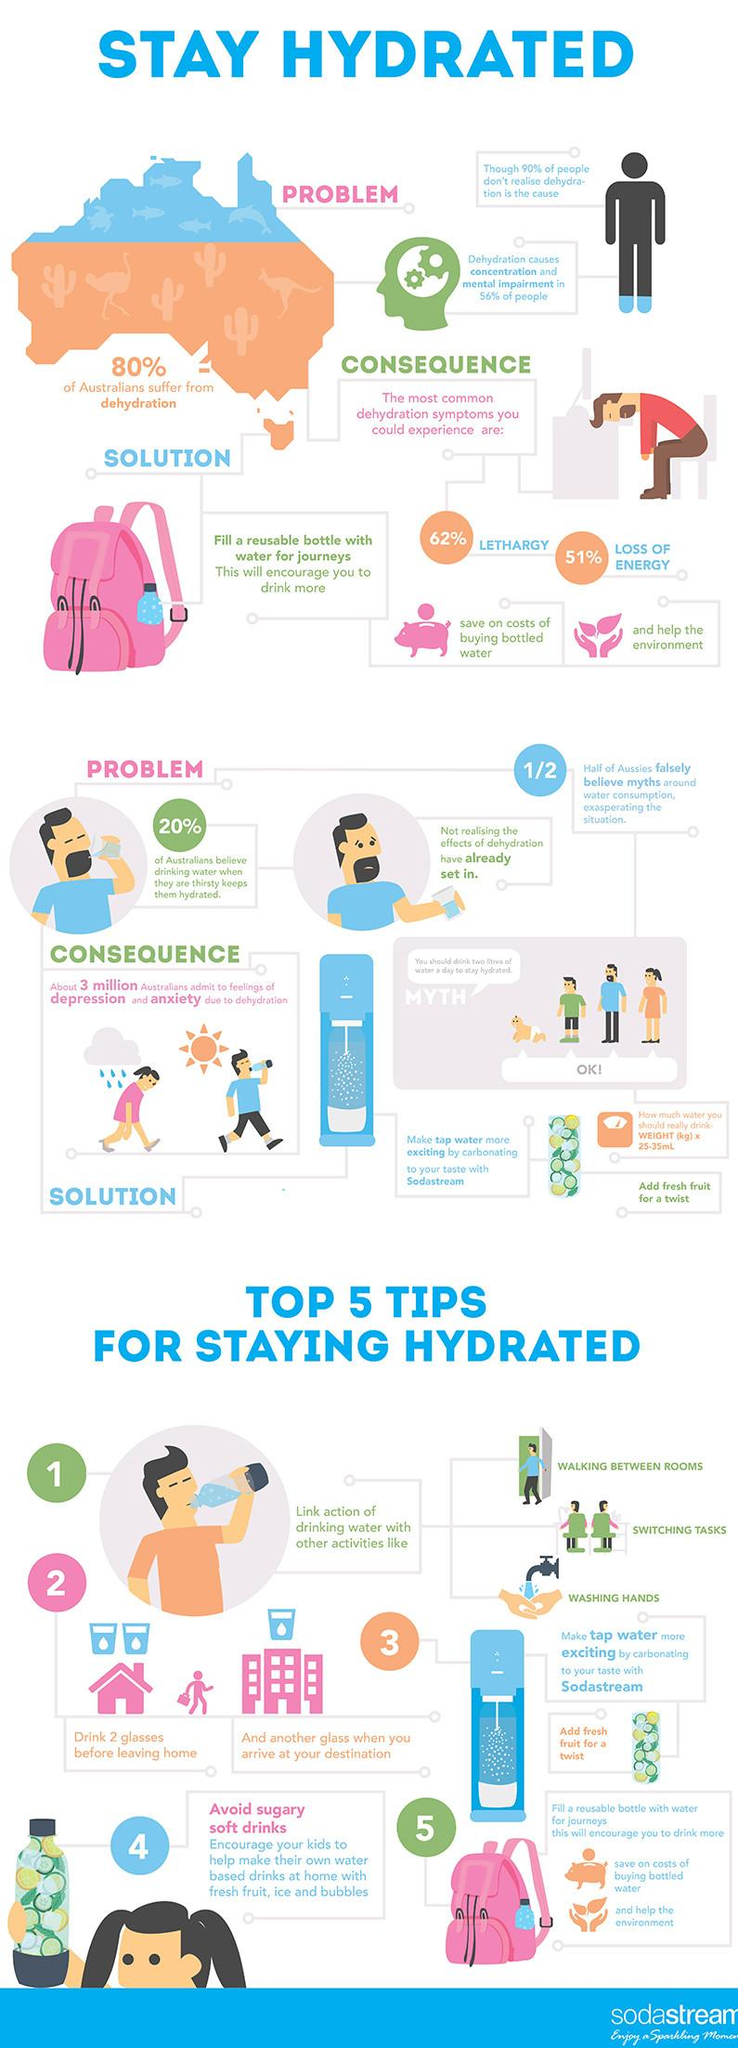Identify some key points in this picture. According to a recent survey, 62% of Australians may experience lethargy as the most common symptom of dehydration. According to a recent survey, approximately 20% of Australians do not suffer from dehydration. According to recent studies, over half of the Australian population, or 51%, may be at risk of experiencing loss of energy due to dehydration, which is a common problem in the country. According to a recent study, 56% of Australians experience concentration and mental impairment due to dehydration. 